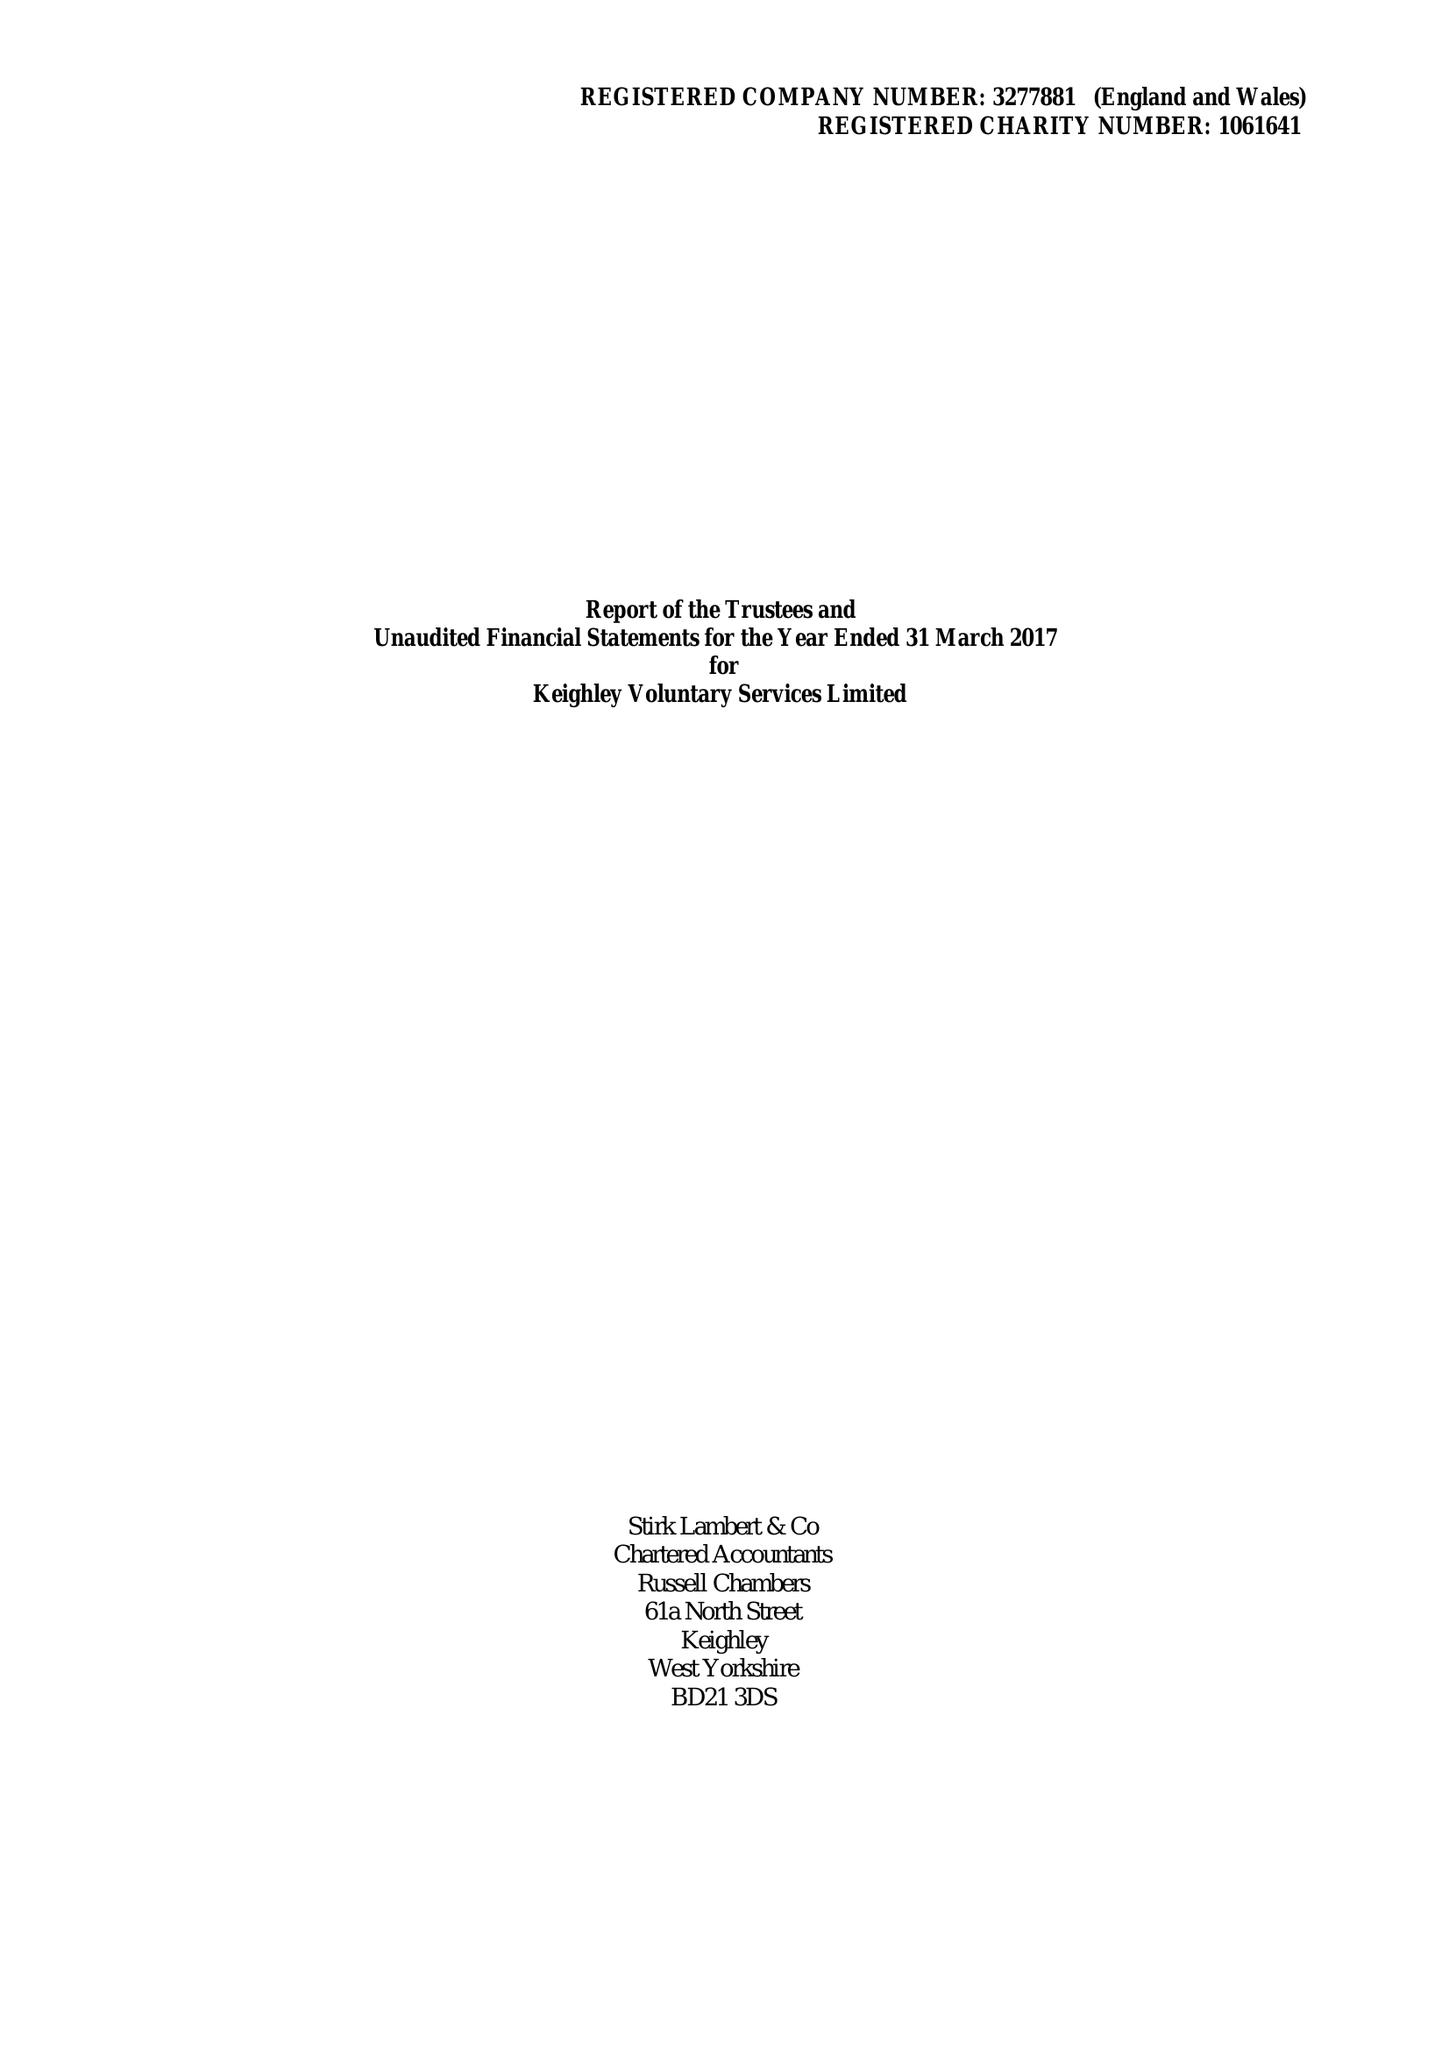What is the value for the income_annually_in_british_pounds?
Answer the question using a single word or phrase. 566005.00 